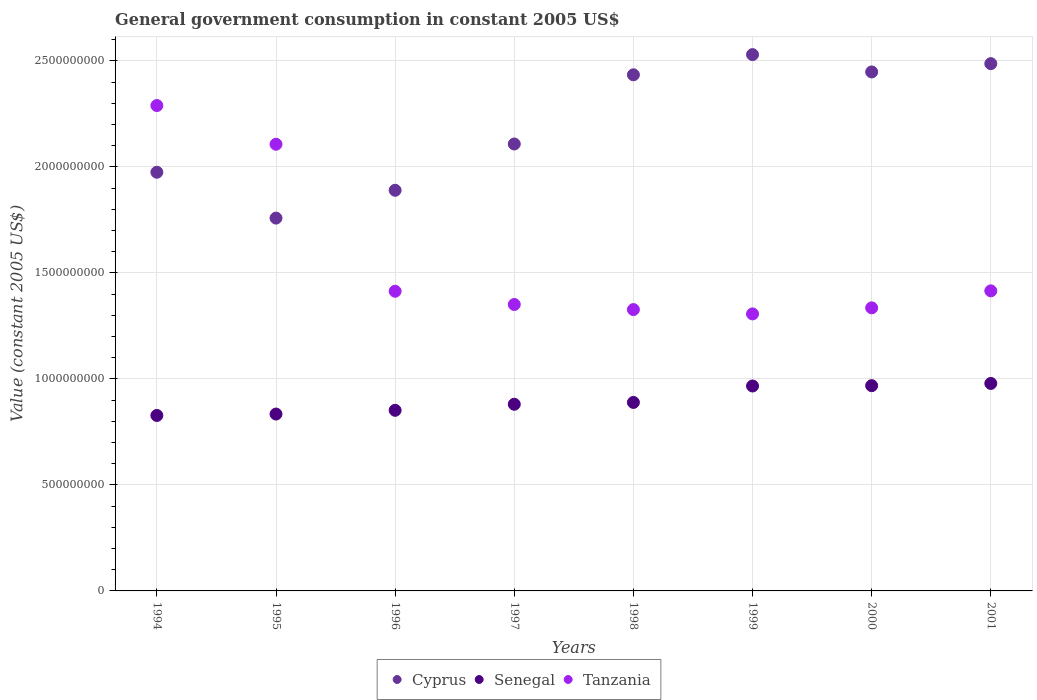Is the number of dotlines equal to the number of legend labels?
Your response must be concise. Yes. What is the government conusmption in Cyprus in 1996?
Your response must be concise. 1.89e+09. Across all years, what is the maximum government conusmption in Senegal?
Provide a succinct answer. 9.79e+08. Across all years, what is the minimum government conusmption in Tanzania?
Offer a very short reply. 1.31e+09. In which year was the government conusmption in Cyprus maximum?
Keep it short and to the point. 1999. In which year was the government conusmption in Cyprus minimum?
Provide a succinct answer. 1995. What is the total government conusmption in Tanzania in the graph?
Your answer should be compact. 1.25e+1. What is the difference between the government conusmption in Tanzania in 1997 and that in 2000?
Offer a very short reply. 1.59e+07. What is the difference between the government conusmption in Senegal in 1997 and the government conusmption in Tanzania in 1996?
Keep it short and to the point. -5.33e+08. What is the average government conusmption in Tanzania per year?
Give a very brief answer. 1.57e+09. In the year 1997, what is the difference between the government conusmption in Senegal and government conusmption in Tanzania?
Your answer should be compact. -4.71e+08. What is the ratio of the government conusmption in Tanzania in 1994 to that in 2001?
Offer a very short reply. 1.62. What is the difference between the highest and the second highest government conusmption in Cyprus?
Offer a very short reply. 4.25e+07. What is the difference between the highest and the lowest government conusmption in Senegal?
Ensure brevity in your answer.  1.51e+08. Is it the case that in every year, the sum of the government conusmption in Tanzania and government conusmption in Cyprus  is greater than the government conusmption in Senegal?
Provide a succinct answer. Yes. Is the government conusmption in Senegal strictly greater than the government conusmption in Tanzania over the years?
Give a very brief answer. No. Is the government conusmption in Tanzania strictly less than the government conusmption in Senegal over the years?
Offer a terse response. No. How many dotlines are there?
Your response must be concise. 3. Are the values on the major ticks of Y-axis written in scientific E-notation?
Ensure brevity in your answer.  No. Where does the legend appear in the graph?
Provide a succinct answer. Bottom center. What is the title of the graph?
Ensure brevity in your answer.  General government consumption in constant 2005 US$. Does "Israel" appear as one of the legend labels in the graph?
Your answer should be compact. No. What is the label or title of the Y-axis?
Provide a short and direct response. Value (constant 2005 US$). What is the Value (constant 2005 US$) of Cyprus in 1994?
Your response must be concise. 1.97e+09. What is the Value (constant 2005 US$) in Senegal in 1994?
Offer a very short reply. 8.28e+08. What is the Value (constant 2005 US$) of Tanzania in 1994?
Offer a very short reply. 2.29e+09. What is the Value (constant 2005 US$) in Cyprus in 1995?
Your answer should be compact. 1.76e+09. What is the Value (constant 2005 US$) in Senegal in 1995?
Offer a very short reply. 8.34e+08. What is the Value (constant 2005 US$) of Tanzania in 1995?
Make the answer very short. 2.11e+09. What is the Value (constant 2005 US$) of Cyprus in 1996?
Give a very brief answer. 1.89e+09. What is the Value (constant 2005 US$) of Senegal in 1996?
Provide a succinct answer. 8.52e+08. What is the Value (constant 2005 US$) of Tanzania in 1996?
Provide a short and direct response. 1.41e+09. What is the Value (constant 2005 US$) in Cyprus in 1997?
Your answer should be very brief. 2.11e+09. What is the Value (constant 2005 US$) of Senegal in 1997?
Provide a short and direct response. 8.80e+08. What is the Value (constant 2005 US$) in Tanzania in 1997?
Offer a very short reply. 1.35e+09. What is the Value (constant 2005 US$) of Cyprus in 1998?
Keep it short and to the point. 2.43e+09. What is the Value (constant 2005 US$) of Senegal in 1998?
Offer a very short reply. 8.89e+08. What is the Value (constant 2005 US$) in Tanzania in 1998?
Give a very brief answer. 1.33e+09. What is the Value (constant 2005 US$) in Cyprus in 1999?
Give a very brief answer. 2.53e+09. What is the Value (constant 2005 US$) in Senegal in 1999?
Provide a succinct answer. 9.67e+08. What is the Value (constant 2005 US$) of Tanzania in 1999?
Make the answer very short. 1.31e+09. What is the Value (constant 2005 US$) in Cyprus in 2000?
Offer a terse response. 2.45e+09. What is the Value (constant 2005 US$) of Senegal in 2000?
Offer a very short reply. 9.68e+08. What is the Value (constant 2005 US$) of Tanzania in 2000?
Provide a short and direct response. 1.34e+09. What is the Value (constant 2005 US$) of Cyprus in 2001?
Ensure brevity in your answer.  2.49e+09. What is the Value (constant 2005 US$) in Senegal in 2001?
Provide a succinct answer. 9.79e+08. What is the Value (constant 2005 US$) of Tanzania in 2001?
Make the answer very short. 1.42e+09. Across all years, what is the maximum Value (constant 2005 US$) of Cyprus?
Ensure brevity in your answer.  2.53e+09. Across all years, what is the maximum Value (constant 2005 US$) of Senegal?
Keep it short and to the point. 9.79e+08. Across all years, what is the maximum Value (constant 2005 US$) of Tanzania?
Make the answer very short. 2.29e+09. Across all years, what is the minimum Value (constant 2005 US$) in Cyprus?
Ensure brevity in your answer.  1.76e+09. Across all years, what is the minimum Value (constant 2005 US$) in Senegal?
Offer a terse response. 8.28e+08. Across all years, what is the minimum Value (constant 2005 US$) of Tanzania?
Provide a succinct answer. 1.31e+09. What is the total Value (constant 2005 US$) of Cyprus in the graph?
Provide a short and direct response. 1.76e+1. What is the total Value (constant 2005 US$) of Senegal in the graph?
Your answer should be very brief. 7.20e+09. What is the total Value (constant 2005 US$) of Tanzania in the graph?
Give a very brief answer. 1.25e+1. What is the difference between the Value (constant 2005 US$) of Cyprus in 1994 and that in 1995?
Provide a short and direct response. 2.16e+08. What is the difference between the Value (constant 2005 US$) in Senegal in 1994 and that in 1995?
Make the answer very short. -6.63e+06. What is the difference between the Value (constant 2005 US$) in Tanzania in 1994 and that in 1995?
Offer a terse response. 1.83e+08. What is the difference between the Value (constant 2005 US$) of Cyprus in 1994 and that in 1996?
Make the answer very short. 8.51e+07. What is the difference between the Value (constant 2005 US$) of Senegal in 1994 and that in 1996?
Your response must be concise. -2.43e+07. What is the difference between the Value (constant 2005 US$) of Tanzania in 1994 and that in 1996?
Offer a terse response. 8.76e+08. What is the difference between the Value (constant 2005 US$) of Cyprus in 1994 and that in 1997?
Your response must be concise. -1.33e+08. What is the difference between the Value (constant 2005 US$) in Senegal in 1994 and that in 1997?
Your response must be concise. -5.28e+07. What is the difference between the Value (constant 2005 US$) of Tanzania in 1994 and that in 1997?
Provide a succinct answer. 9.38e+08. What is the difference between the Value (constant 2005 US$) of Cyprus in 1994 and that in 1998?
Offer a terse response. -4.60e+08. What is the difference between the Value (constant 2005 US$) of Senegal in 1994 and that in 1998?
Keep it short and to the point. -6.14e+07. What is the difference between the Value (constant 2005 US$) of Tanzania in 1994 and that in 1998?
Keep it short and to the point. 9.62e+08. What is the difference between the Value (constant 2005 US$) in Cyprus in 1994 and that in 1999?
Your answer should be very brief. -5.55e+08. What is the difference between the Value (constant 2005 US$) of Senegal in 1994 and that in 1999?
Keep it short and to the point. -1.39e+08. What is the difference between the Value (constant 2005 US$) of Tanzania in 1994 and that in 1999?
Your answer should be compact. 9.83e+08. What is the difference between the Value (constant 2005 US$) in Cyprus in 1994 and that in 2000?
Ensure brevity in your answer.  -4.73e+08. What is the difference between the Value (constant 2005 US$) of Senegal in 1994 and that in 2000?
Provide a short and direct response. -1.41e+08. What is the difference between the Value (constant 2005 US$) of Tanzania in 1994 and that in 2000?
Your answer should be very brief. 9.54e+08. What is the difference between the Value (constant 2005 US$) of Cyprus in 1994 and that in 2001?
Make the answer very short. -5.12e+08. What is the difference between the Value (constant 2005 US$) of Senegal in 1994 and that in 2001?
Your response must be concise. -1.51e+08. What is the difference between the Value (constant 2005 US$) in Tanzania in 1994 and that in 2001?
Your answer should be very brief. 8.74e+08. What is the difference between the Value (constant 2005 US$) of Cyprus in 1995 and that in 1996?
Your answer should be very brief. -1.31e+08. What is the difference between the Value (constant 2005 US$) of Senegal in 1995 and that in 1996?
Give a very brief answer. -1.76e+07. What is the difference between the Value (constant 2005 US$) in Tanzania in 1995 and that in 1996?
Your response must be concise. 6.93e+08. What is the difference between the Value (constant 2005 US$) of Cyprus in 1995 and that in 1997?
Give a very brief answer. -3.50e+08. What is the difference between the Value (constant 2005 US$) in Senegal in 1995 and that in 1997?
Provide a short and direct response. -4.61e+07. What is the difference between the Value (constant 2005 US$) of Tanzania in 1995 and that in 1997?
Provide a succinct answer. 7.56e+08. What is the difference between the Value (constant 2005 US$) of Cyprus in 1995 and that in 1998?
Your answer should be compact. -6.76e+08. What is the difference between the Value (constant 2005 US$) of Senegal in 1995 and that in 1998?
Give a very brief answer. -5.48e+07. What is the difference between the Value (constant 2005 US$) of Tanzania in 1995 and that in 1998?
Keep it short and to the point. 7.80e+08. What is the difference between the Value (constant 2005 US$) of Cyprus in 1995 and that in 1999?
Your answer should be very brief. -7.71e+08. What is the difference between the Value (constant 2005 US$) in Senegal in 1995 and that in 1999?
Your answer should be very brief. -1.32e+08. What is the difference between the Value (constant 2005 US$) in Tanzania in 1995 and that in 1999?
Give a very brief answer. 8.00e+08. What is the difference between the Value (constant 2005 US$) in Cyprus in 1995 and that in 2000?
Ensure brevity in your answer.  -6.89e+08. What is the difference between the Value (constant 2005 US$) of Senegal in 1995 and that in 2000?
Give a very brief answer. -1.34e+08. What is the difference between the Value (constant 2005 US$) of Tanzania in 1995 and that in 2000?
Provide a short and direct response. 7.72e+08. What is the difference between the Value (constant 2005 US$) of Cyprus in 1995 and that in 2001?
Provide a succinct answer. -7.29e+08. What is the difference between the Value (constant 2005 US$) of Senegal in 1995 and that in 2001?
Give a very brief answer. -1.44e+08. What is the difference between the Value (constant 2005 US$) of Tanzania in 1995 and that in 2001?
Ensure brevity in your answer.  6.92e+08. What is the difference between the Value (constant 2005 US$) in Cyprus in 1996 and that in 1997?
Your answer should be compact. -2.18e+08. What is the difference between the Value (constant 2005 US$) in Senegal in 1996 and that in 1997?
Make the answer very short. -2.85e+07. What is the difference between the Value (constant 2005 US$) of Tanzania in 1996 and that in 1997?
Your response must be concise. 6.24e+07. What is the difference between the Value (constant 2005 US$) of Cyprus in 1996 and that in 1998?
Provide a short and direct response. -5.45e+08. What is the difference between the Value (constant 2005 US$) of Senegal in 1996 and that in 1998?
Give a very brief answer. -3.72e+07. What is the difference between the Value (constant 2005 US$) in Tanzania in 1996 and that in 1998?
Your answer should be compact. 8.64e+07. What is the difference between the Value (constant 2005 US$) in Cyprus in 1996 and that in 1999?
Keep it short and to the point. -6.40e+08. What is the difference between the Value (constant 2005 US$) in Senegal in 1996 and that in 1999?
Keep it short and to the point. -1.15e+08. What is the difference between the Value (constant 2005 US$) of Tanzania in 1996 and that in 1999?
Give a very brief answer. 1.07e+08. What is the difference between the Value (constant 2005 US$) of Cyprus in 1996 and that in 2000?
Offer a very short reply. -5.58e+08. What is the difference between the Value (constant 2005 US$) in Senegal in 1996 and that in 2000?
Your answer should be very brief. -1.16e+08. What is the difference between the Value (constant 2005 US$) of Tanzania in 1996 and that in 2000?
Give a very brief answer. 7.83e+07. What is the difference between the Value (constant 2005 US$) in Cyprus in 1996 and that in 2001?
Your answer should be compact. -5.97e+08. What is the difference between the Value (constant 2005 US$) in Senegal in 1996 and that in 2001?
Ensure brevity in your answer.  -1.27e+08. What is the difference between the Value (constant 2005 US$) of Tanzania in 1996 and that in 2001?
Offer a terse response. -1.82e+06. What is the difference between the Value (constant 2005 US$) in Cyprus in 1997 and that in 1998?
Your answer should be compact. -3.26e+08. What is the difference between the Value (constant 2005 US$) in Senegal in 1997 and that in 1998?
Provide a short and direct response. -8.65e+06. What is the difference between the Value (constant 2005 US$) of Tanzania in 1997 and that in 1998?
Offer a very short reply. 2.41e+07. What is the difference between the Value (constant 2005 US$) of Cyprus in 1997 and that in 1999?
Your answer should be compact. -4.22e+08. What is the difference between the Value (constant 2005 US$) in Senegal in 1997 and that in 1999?
Keep it short and to the point. -8.62e+07. What is the difference between the Value (constant 2005 US$) in Tanzania in 1997 and that in 1999?
Keep it short and to the point. 4.45e+07. What is the difference between the Value (constant 2005 US$) of Cyprus in 1997 and that in 2000?
Ensure brevity in your answer.  -3.40e+08. What is the difference between the Value (constant 2005 US$) of Senegal in 1997 and that in 2000?
Provide a succinct answer. -8.77e+07. What is the difference between the Value (constant 2005 US$) in Tanzania in 1997 and that in 2000?
Ensure brevity in your answer.  1.59e+07. What is the difference between the Value (constant 2005 US$) in Cyprus in 1997 and that in 2001?
Provide a succinct answer. -3.79e+08. What is the difference between the Value (constant 2005 US$) in Senegal in 1997 and that in 2001?
Provide a succinct answer. -9.82e+07. What is the difference between the Value (constant 2005 US$) in Tanzania in 1997 and that in 2001?
Ensure brevity in your answer.  -6.42e+07. What is the difference between the Value (constant 2005 US$) of Cyprus in 1998 and that in 1999?
Provide a succinct answer. -9.52e+07. What is the difference between the Value (constant 2005 US$) of Senegal in 1998 and that in 1999?
Your answer should be compact. -7.76e+07. What is the difference between the Value (constant 2005 US$) of Tanzania in 1998 and that in 1999?
Provide a short and direct response. 2.05e+07. What is the difference between the Value (constant 2005 US$) in Cyprus in 1998 and that in 2000?
Provide a short and direct response. -1.35e+07. What is the difference between the Value (constant 2005 US$) in Senegal in 1998 and that in 2000?
Give a very brief answer. -7.91e+07. What is the difference between the Value (constant 2005 US$) of Tanzania in 1998 and that in 2000?
Offer a terse response. -8.16e+06. What is the difference between the Value (constant 2005 US$) in Cyprus in 1998 and that in 2001?
Keep it short and to the point. -5.26e+07. What is the difference between the Value (constant 2005 US$) of Senegal in 1998 and that in 2001?
Your response must be concise. -8.96e+07. What is the difference between the Value (constant 2005 US$) in Tanzania in 1998 and that in 2001?
Your response must be concise. -8.83e+07. What is the difference between the Value (constant 2005 US$) in Cyprus in 1999 and that in 2000?
Give a very brief answer. 8.17e+07. What is the difference between the Value (constant 2005 US$) in Senegal in 1999 and that in 2000?
Provide a succinct answer. -1.54e+06. What is the difference between the Value (constant 2005 US$) in Tanzania in 1999 and that in 2000?
Ensure brevity in your answer.  -2.86e+07. What is the difference between the Value (constant 2005 US$) of Cyprus in 1999 and that in 2001?
Offer a very short reply. 4.25e+07. What is the difference between the Value (constant 2005 US$) of Senegal in 1999 and that in 2001?
Your answer should be very brief. -1.20e+07. What is the difference between the Value (constant 2005 US$) in Tanzania in 1999 and that in 2001?
Offer a terse response. -1.09e+08. What is the difference between the Value (constant 2005 US$) in Cyprus in 2000 and that in 2001?
Give a very brief answer. -3.92e+07. What is the difference between the Value (constant 2005 US$) of Senegal in 2000 and that in 2001?
Make the answer very short. -1.05e+07. What is the difference between the Value (constant 2005 US$) in Tanzania in 2000 and that in 2001?
Offer a very short reply. -8.01e+07. What is the difference between the Value (constant 2005 US$) in Cyprus in 1994 and the Value (constant 2005 US$) in Senegal in 1995?
Give a very brief answer. 1.14e+09. What is the difference between the Value (constant 2005 US$) of Cyprus in 1994 and the Value (constant 2005 US$) of Tanzania in 1995?
Ensure brevity in your answer.  -1.32e+08. What is the difference between the Value (constant 2005 US$) in Senegal in 1994 and the Value (constant 2005 US$) in Tanzania in 1995?
Keep it short and to the point. -1.28e+09. What is the difference between the Value (constant 2005 US$) of Cyprus in 1994 and the Value (constant 2005 US$) of Senegal in 1996?
Keep it short and to the point. 1.12e+09. What is the difference between the Value (constant 2005 US$) of Cyprus in 1994 and the Value (constant 2005 US$) of Tanzania in 1996?
Keep it short and to the point. 5.61e+08. What is the difference between the Value (constant 2005 US$) of Senegal in 1994 and the Value (constant 2005 US$) of Tanzania in 1996?
Keep it short and to the point. -5.86e+08. What is the difference between the Value (constant 2005 US$) in Cyprus in 1994 and the Value (constant 2005 US$) in Senegal in 1997?
Give a very brief answer. 1.09e+09. What is the difference between the Value (constant 2005 US$) in Cyprus in 1994 and the Value (constant 2005 US$) in Tanzania in 1997?
Offer a terse response. 6.24e+08. What is the difference between the Value (constant 2005 US$) of Senegal in 1994 and the Value (constant 2005 US$) of Tanzania in 1997?
Give a very brief answer. -5.23e+08. What is the difference between the Value (constant 2005 US$) in Cyprus in 1994 and the Value (constant 2005 US$) in Senegal in 1998?
Offer a terse response. 1.09e+09. What is the difference between the Value (constant 2005 US$) in Cyprus in 1994 and the Value (constant 2005 US$) in Tanzania in 1998?
Your response must be concise. 6.48e+08. What is the difference between the Value (constant 2005 US$) of Senegal in 1994 and the Value (constant 2005 US$) of Tanzania in 1998?
Offer a terse response. -4.99e+08. What is the difference between the Value (constant 2005 US$) of Cyprus in 1994 and the Value (constant 2005 US$) of Senegal in 1999?
Offer a very short reply. 1.01e+09. What is the difference between the Value (constant 2005 US$) of Cyprus in 1994 and the Value (constant 2005 US$) of Tanzania in 1999?
Keep it short and to the point. 6.68e+08. What is the difference between the Value (constant 2005 US$) of Senegal in 1994 and the Value (constant 2005 US$) of Tanzania in 1999?
Offer a terse response. -4.79e+08. What is the difference between the Value (constant 2005 US$) of Cyprus in 1994 and the Value (constant 2005 US$) of Senegal in 2000?
Your response must be concise. 1.01e+09. What is the difference between the Value (constant 2005 US$) of Cyprus in 1994 and the Value (constant 2005 US$) of Tanzania in 2000?
Keep it short and to the point. 6.40e+08. What is the difference between the Value (constant 2005 US$) in Senegal in 1994 and the Value (constant 2005 US$) in Tanzania in 2000?
Make the answer very short. -5.08e+08. What is the difference between the Value (constant 2005 US$) of Cyprus in 1994 and the Value (constant 2005 US$) of Senegal in 2001?
Ensure brevity in your answer.  9.96e+08. What is the difference between the Value (constant 2005 US$) in Cyprus in 1994 and the Value (constant 2005 US$) in Tanzania in 2001?
Keep it short and to the point. 5.59e+08. What is the difference between the Value (constant 2005 US$) of Senegal in 1994 and the Value (constant 2005 US$) of Tanzania in 2001?
Make the answer very short. -5.88e+08. What is the difference between the Value (constant 2005 US$) in Cyprus in 1995 and the Value (constant 2005 US$) in Senegal in 1996?
Provide a succinct answer. 9.07e+08. What is the difference between the Value (constant 2005 US$) in Cyprus in 1995 and the Value (constant 2005 US$) in Tanzania in 1996?
Your response must be concise. 3.45e+08. What is the difference between the Value (constant 2005 US$) in Senegal in 1995 and the Value (constant 2005 US$) in Tanzania in 1996?
Offer a terse response. -5.79e+08. What is the difference between the Value (constant 2005 US$) of Cyprus in 1995 and the Value (constant 2005 US$) of Senegal in 1997?
Your answer should be compact. 8.78e+08. What is the difference between the Value (constant 2005 US$) of Cyprus in 1995 and the Value (constant 2005 US$) of Tanzania in 1997?
Provide a short and direct response. 4.07e+08. What is the difference between the Value (constant 2005 US$) in Senegal in 1995 and the Value (constant 2005 US$) in Tanzania in 1997?
Offer a terse response. -5.17e+08. What is the difference between the Value (constant 2005 US$) in Cyprus in 1995 and the Value (constant 2005 US$) in Senegal in 1998?
Provide a succinct answer. 8.69e+08. What is the difference between the Value (constant 2005 US$) of Cyprus in 1995 and the Value (constant 2005 US$) of Tanzania in 1998?
Offer a terse response. 4.32e+08. What is the difference between the Value (constant 2005 US$) in Senegal in 1995 and the Value (constant 2005 US$) in Tanzania in 1998?
Keep it short and to the point. -4.93e+08. What is the difference between the Value (constant 2005 US$) in Cyprus in 1995 and the Value (constant 2005 US$) in Senegal in 1999?
Offer a terse response. 7.92e+08. What is the difference between the Value (constant 2005 US$) of Cyprus in 1995 and the Value (constant 2005 US$) of Tanzania in 1999?
Ensure brevity in your answer.  4.52e+08. What is the difference between the Value (constant 2005 US$) in Senegal in 1995 and the Value (constant 2005 US$) in Tanzania in 1999?
Offer a very short reply. -4.72e+08. What is the difference between the Value (constant 2005 US$) of Cyprus in 1995 and the Value (constant 2005 US$) of Senegal in 2000?
Give a very brief answer. 7.90e+08. What is the difference between the Value (constant 2005 US$) of Cyprus in 1995 and the Value (constant 2005 US$) of Tanzania in 2000?
Your response must be concise. 4.23e+08. What is the difference between the Value (constant 2005 US$) of Senegal in 1995 and the Value (constant 2005 US$) of Tanzania in 2000?
Your answer should be compact. -5.01e+08. What is the difference between the Value (constant 2005 US$) in Cyprus in 1995 and the Value (constant 2005 US$) in Senegal in 2001?
Your answer should be very brief. 7.80e+08. What is the difference between the Value (constant 2005 US$) of Cyprus in 1995 and the Value (constant 2005 US$) of Tanzania in 2001?
Offer a terse response. 3.43e+08. What is the difference between the Value (constant 2005 US$) of Senegal in 1995 and the Value (constant 2005 US$) of Tanzania in 2001?
Keep it short and to the point. -5.81e+08. What is the difference between the Value (constant 2005 US$) of Cyprus in 1996 and the Value (constant 2005 US$) of Senegal in 1997?
Your answer should be compact. 1.01e+09. What is the difference between the Value (constant 2005 US$) in Cyprus in 1996 and the Value (constant 2005 US$) in Tanzania in 1997?
Your response must be concise. 5.39e+08. What is the difference between the Value (constant 2005 US$) of Senegal in 1996 and the Value (constant 2005 US$) of Tanzania in 1997?
Give a very brief answer. -4.99e+08. What is the difference between the Value (constant 2005 US$) of Cyprus in 1996 and the Value (constant 2005 US$) of Senegal in 1998?
Offer a terse response. 1.00e+09. What is the difference between the Value (constant 2005 US$) in Cyprus in 1996 and the Value (constant 2005 US$) in Tanzania in 1998?
Your answer should be compact. 5.63e+08. What is the difference between the Value (constant 2005 US$) in Senegal in 1996 and the Value (constant 2005 US$) in Tanzania in 1998?
Keep it short and to the point. -4.75e+08. What is the difference between the Value (constant 2005 US$) of Cyprus in 1996 and the Value (constant 2005 US$) of Senegal in 1999?
Give a very brief answer. 9.23e+08. What is the difference between the Value (constant 2005 US$) of Cyprus in 1996 and the Value (constant 2005 US$) of Tanzania in 1999?
Offer a very short reply. 5.83e+08. What is the difference between the Value (constant 2005 US$) of Senegal in 1996 and the Value (constant 2005 US$) of Tanzania in 1999?
Give a very brief answer. -4.55e+08. What is the difference between the Value (constant 2005 US$) of Cyprus in 1996 and the Value (constant 2005 US$) of Senegal in 2000?
Ensure brevity in your answer.  9.22e+08. What is the difference between the Value (constant 2005 US$) in Cyprus in 1996 and the Value (constant 2005 US$) in Tanzania in 2000?
Provide a short and direct response. 5.55e+08. What is the difference between the Value (constant 2005 US$) of Senegal in 1996 and the Value (constant 2005 US$) of Tanzania in 2000?
Offer a very short reply. -4.83e+08. What is the difference between the Value (constant 2005 US$) of Cyprus in 1996 and the Value (constant 2005 US$) of Senegal in 2001?
Your response must be concise. 9.11e+08. What is the difference between the Value (constant 2005 US$) in Cyprus in 1996 and the Value (constant 2005 US$) in Tanzania in 2001?
Make the answer very short. 4.74e+08. What is the difference between the Value (constant 2005 US$) of Senegal in 1996 and the Value (constant 2005 US$) of Tanzania in 2001?
Provide a short and direct response. -5.63e+08. What is the difference between the Value (constant 2005 US$) in Cyprus in 1997 and the Value (constant 2005 US$) in Senegal in 1998?
Your answer should be compact. 1.22e+09. What is the difference between the Value (constant 2005 US$) in Cyprus in 1997 and the Value (constant 2005 US$) in Tanzania in 1998?
Keep it short and to the point. 7.81e+08. What is the difference between the Value (constant 2005 US$) in Senegal in 1997 and the Value (constant 2005 US$) in Tanzania in 1998?
Provide a succinct answer. -4.47e+08. What is the difference between the Value (constant 2005 US$) in Cyprus in 1997 and the Value (constant 2005 US$) in Senegal in 1999?
Offer a terse response. 1.14e+09. What is the difference between the Value (constant 2005 US$) of Cyprus in 1997 and the Value (constant 2005 US$) of Tanzania in 1999?
Provide a short and direct response. 8.01e+08. What is the difference between the Value (constant 2005 US$) in Senegal in 1997 and the Value (constant 2005 US$) in Tanzania in 1999?
Provide a succinct answer. -4.26e+08. What is the difference between the Value (constant 2005 US$) in Cyprus in 1997 and the Value (constant 2005 US$) in Senegal in 2000?
Provide a succinct answer. 1.14e+09. What is the difference between the Value (constant 2005 US$) in Cyprus in 1997 and the Value (constant 2005 US$) in Tanzania in 2000?
Offer a very short reply. 7.73e+08. What is the difference between the Value (constant 2005 US$) in Senegal in 1997 and the Value (constant 2005 US$) in Tanzania in 2000?
Provide a succinct answer. -4.55e+08. What is the difference between the Value (constant 2005 US$) in Cyprus in 1997 and the Value (constant 2005 US$) in Senegal in 2001?
Ensure brevity in your answer.  1.13e+09. What is the difference between the Value (constant 2005 US$) of Cyprus in 1997 and the Value (constant 2005 US$) of Tanzania in 2001?
Your answer should be compact. 6.93e+08. What is the difference between the Value (constant 2005 US$) of Senegal in 1997 and the Value (constant 2005 US$) of Tanzania in 2001?
Make the answer very short. -5.35e+08. What is the difference between the Value (constant 2005 US$) of Cyprus in 1998 and the Value (constant 2005 US$) of Senegal in 1999?
Provide a succinct answer. 1.47e+09. What is the difference between the Value (constant 2005 US$) in Cyprus in 1998 and the Value (constant 2005 US$) in Tanzania in 1999?
Offer a very short reply. 1.13e+09. What is the difference between the Value (constant 2005 US$) in Senegal in 1998 and the Value (constant 2005 US$) in Tanzania in 1999?
Give a very brief answer. -4.17e+08. What is the difference between the Value (constant 2005 US$) of Cyprus in 1998 and the Value (constant 2005 US$) of Senegal in 2000?
Offer a very short reply. 1.47e+09. What is the difference between the Value (constant 2005 US$) in Cyprus in 1998 and the Value (constant 2005 US$) in Tanzania in 2000?
Make the answer very short. 1.10e+09. What is the difference between the Value (constant 2005 US$) of Senegal in 1998 and the Value (constant 2005 US$) of Tanzania in 2000?
Provide a short and direct response. -4.46e+08. What is the difference between the Value (constant 2005 US$) of Cyprus in 1998 and the Value (constant 2005 US$) of Senegal in 2001?
Your response must be concise. 1.46e+09. What is the difference between the Value (constant 2005 US$) in Cyprus in 1998 and the Value (constant 2005 US$) in Tanzania in 2001?
Give a very brief answer. 1.02e+09. What is the difference between the Value (constant 2005 US$) in Senegal in 1998 and the Value (constant 2005 US$) in Tanzania in 2001?
Provide a succinct answer. -5.26e+08. What is the difference between the Value (constant 2005 US$) in Cyprus in 1999 and the Value (constant 2005 US$) in Senegal in 2000?
Your response must be concise. 1.56e+09. What is the difference between the Value (constant 2005 US$) in Cyprus in 1999 and the Value (constant 2005 US$) in Tanzania in 2000?
Provide a succinct answer. 1.19e+09. What is the difference between the Value (constant 2005 US$) in Senegal in 1999 and the Value (constant 2005 US$) in Tanzania in 2000?
Ensure brevity in your answer.  -3.69e+08. What is the difference between the Value (constant 2005 US$) of Cyprus in 1999 and the Value (constant 2005 US$) of Senegal in 2001?
Offer a terse response. 1.55e+09. What is the difference between the Value (constant 2005 US$) of Cyprus in 1999 and the Value (constant 2005 US$) of Tanzania in 2001?
Make the answer very short. 1.11e+09. What is the difference between the Value (constant 2005 US$) of Senegal in 1999 and the Value (constant 2005 US$) of Tanzania in 2001?
Offer a very short reply. -4.49e+08. What is the difference between the Value (constant 2005 US$) in Cyprus in 2000 and the Value (constant 2005 US$) in Senegal in 2001?
Make the answer very short. 1.47e+09. What is the difference between the Value (constant 2005 US$) of Cyprus in 2000 and the Value (constant 2005 US$) of Tanzania in 2001?
Ensure brevity in your answer.  1.03e+09. What is the difference between the Value (constant 2005 US$) in Senegal in 2000 and the Value (constant 2005 US$) in Tanzania in 2001?
Your response must be concise. -4.47e+08. What is the average Value (constant 2005 US$) of Cyprus per year?
Provide a short and direct response. 2.20e+09. What is the average Value (constant 2005 US$) in Senegal per year?
Provide a short and direct response. 9.00e+08. What is the average Value (constant 2005 US$) in Tanzania per year?
Keep it short and to the point. 1.57e+09. In the year 1994, what is the difference between the Value (constant 2005 US$) of Cyprus and Value (constant 2005 US$) of Senegal?
Provide a short and direct response. 1.15e+09. In the year 1994, what is the difference between the Value (constant 2005 US$) in Cyprus and Value (constant 2005 US$) in Tanzania?
Your response must be concise. -3.15e+08. In the year 1994, what is the difference between the Value (constant 2005 US$) in Senegal and Value (constant 2005 US$) in Tanzania?
Provide a short and direct response. -1.46e+09. In the year 1995, what is the difference between the Value (constant 2005 US$) of Cyprus and Value (constant 2005 US$) of Senegal?
Give a very brief answer. 9.24e+08. In the year 1995, what is the difference between the Value (constant 2005 US$) in Cyprus and Value (constant 2005 US$) in Tanzania?
Provide a short and direct response. -3.48e+08. In the year 1995, what is the difference between the Value (constant 2005 US$) of Senegal and Value (constant 2005 US$) of Tanzania?
Offer a very short reply. -1.27e+09. In the year 1996, what is the difference between the Value (constant 2005 US$) of Cyprus and Value (constant 2005 US$) of Senegal?
Keep it short and to the point. 1.04e+09. In the year 1996, what is the difference between the Value (constant 2005 US$) of Cyprus and Value (constant 2005 US$) of Tanzania?
Your answer should be compact. 4.76e+08. In the year 1996, what is the difference between the Value (constant 2005 US$) in Senegal and Value (constant 2005 US$) in Tanzania?
Provide a succinct answer. -5.62e+08. In the year 1997, what is the difference between the Value (constant 2005 US$) in Cyprus and Value (constant 2005 US$) in Senegal?
Provide a succinct answer. 1.23e+09. In the year 1997, what is the difference between the Value (constant 2005 US$) of Cyprus and Value (constant 2005 US$) of Tanzania?
Your response must be concise. 7.57e+08. In the year 1997, what is the difference between the Value (constant 2005 US$) in Senegal and Value (constant 2005 US$) in Tanzania?
Provide a short and direct response. -4.71e+08. In the year 1998, what is the difference between the Value (constant 2005 US$) of Cyprus and Value (constant 2005 US$) of Senegal?
Give a very brief answer. 1.55e+09. In the year 1998, what is the difference between the Value (constant 2005 US$) in Cyprus and Value (constant 2005 US$) in Tanzania?
Provide a succinct answer. 1.11e+09. In the year 1998, what is the difference between the Value (constant 2005 US$) of Senegal and Value (constant 2005 US$) of Tanzania?
Offer a very short reply. -4.38e+08. In the year 1999, what is the difference between the Value (constant 2005 US$) in Cyprus and Value (constant 2005 US$) in Senegal?
Offer a very short reply. 1.56e+09. In the year 1999, what is the difference between the Value (constant 2005 US$) in Cyprus and Value (constant 2005 US$) in Tanzania?
Provide a short and direct response. 1.22e+09. In the year 1999, what is the difference between the Value (constant 2005 US$) of Senegal and Value (constant 2005 US$) of Tanzania?
Keep it short and to the point. -3.40e+08. In the year 2000, what is the difference between the Value (constant 2005 US$) in Cyprus and Value (constant 2005 US$) in Senegal?
Offer a very short reply. 1.48e+09. In the year 2000, what is the difference between the Value (constant 2005 US$) in Cyprus and Value (constant 2005 US$) in Tanzania?
Offer a very short reply. 1.11e+09. In the year 2000, what is the difference between the Value (constant 2005 US$) in Senegal and Value (constant 2005 US$) in Tanzania?
Ensure brevity in your answer.  -3.67e+08. In the year 2001, what is the difference between the Value (constant 2005 US$) in Cyprus and Value (constant 2005 US$) in Senegal?
Your response must be concise. 1.51e+09. In the year 2001, what is the difference between the Value (constant 2005 US$) of Cyprus and Value (constant 2005 US$) of Tanzania?
Your answer should be very brief. 1.07e+09. In the year 2001, what is the difference between the Value (constant 2005 US$) of Senegal and Value (constant 2005 US$) of Tanzania?
Keep it short and to the point. -4.37e+08. What is the ratio of the Value (constant 2005 US$) of Cyprus in 1994 to that in 1995?
Keep it short and to the point. 1.12. What is the ratio of the Value (constant 2005 US$) of Senegal in 1994 to that in 1995?
Make the answer very short. 0.99. What is the ratio of the Value (constant 2005 US$) of Tanzania in 1994 to that in 1995?
Offer a very short reply. 1.09. What is the ratio of the Value (constant 2005 US$) in Cyprus in 1994 to that in 1996?
Give a very brief answer. 1.04. What is the ratio of the Value (constant 2005 US$) in Senegal in 1994 to that in 1996?
Ensure brevity in your answer.  0.97. What is the ratio of the Value (constant 2005 US$) in Tanzania in 1994 to that in 1996?
Provide a short and direct response. 1.62. What is the ratio of the Value (constant 2005 US$) of Cyprus in 1994 to that in 1997?
Offer a very short reply. 0.94. What is the ratio of the Value (constant 2005 US$) of Senegal in 1994 to that in 1997?
Keep it short and to the point. 0.94. What is the ratio of the Value (constant 2005 US$) of Tanzania in 1994 to that in 1997?
Provide a short and direct response. 1.69. What is the ratio of the Value (constant 2005 US$) of Cyprus in 1994 to that in 1998?
Offer a terse response. 0.81. What is the ratio of the Value (constant 2005 US$) in Senegal in 1994 to that in 1998?
Give a very brief answer. 0.93. What is the ratio of the Value (constant 2005 US$) of Tanzania in 1994 to that in 1998?
Your answer should be compact. 1.73. What is the ratio of the Value (constant 2005 US$) in Cyprus in 1994 to that in 1999?
Provide a succinct answer. 0.78. What is the ratio of the Value (constant 2005 US$) of Senegal in 1994 to that in 1999?
Provide a short and direct response. 0.86. What is the ratio of the Value (constant 2005 US$) in Tanzania in 1994 to that in 1999?
Offer a terse response. 1.75. What is the ratio of the Value (constant 2005 US$) in Cyprus in 1994 to that in 2000?
Provide a short and direct response. 0.81. What is the ratio of the Value (constant 2005 US$) of Senegal in 1994 to that in 2000?
Keep it short and to the point. 0.85. What is the ratio of the Value (constant 2005 US$) in Tanzania in 1994 to that in 2000?
Your answer should be very brief. 1.71. What is the ratio of the Value (constant 2005 US$) in Cyprus in 1994 to that in 2001?
Provide a succinct answer. 0.79. What is the ratio of the Value (constant 2005 US$) of Senegal in 1994 to that in 2001?
Make the answer very short. 0.85. What is the ratio of the Value (constant 2005 US$) of Tanzania in 1994 to that in 2001?
Provide a short and direct response. 1.62. What is the ratio of the Value (constant 2005 US$) of Cyprus in 1995 to that in 1996?
Keep it short and to the point. 0.93. What is the ratio of the Value (constant 2005 US$) of Senegal in 1995 to that in 1996?
Your answer should be compact. 0.98. What is the ratio of the Value (constant 2005 US$) in Tanzania in 1995 to that in 1996?
Your answer should be compact. 1.49. What is the ratio of the Value (constant 2005 US$) in Cyprus in 1995 to that in 1997?
Keep it short and to the point. 0.83. What is the ratio of the Value (constant 2005 US$) of Senegal in 1995 to that in 1997?
Give a very brief answer. 0.95. What is the ratio of the Value (constant 2005 US$) of Tanzania in 1995 to that in 1997?
Your response must be concise. 1.56. What is the ratio of the Value (constant 2005 US$) of Cyprus in 1995 to that in 1998?
Provide a short and direct response. 0.72. What is the ratio of the Value (constant 2005 US$) in Senegal in 1995 to that in 1998?
Ensure brevity in your answer.  0.94. What is the ratio of the Value (constant 2005 US$) of Tanzania in 1995 to that in 1998?
Give a very brief answer. 1.59. What is the ratio of the Value (constant 2005 US$) of Cyprus in 1995 to that in 1999?
Provide a succinct answer. 0.7. What is the ratio of the Value (constant 2005 US$) of Senegal in 1995 to that in 1999?
Provide a succinct answer. 0.86. What is the ratio of the Value (constant 2005 US$) of Tanzania in 1995 to that in 1999?
Ensure brevity in your answer.  1.61. What is the ratio of the Value (constant 2005 US$) of Cyprus in 1995 to that in 2000?
Keep it short and to the point. 0.72. What is the ratio of the Value (constant 2005 US$) in Senegal in 1995 to that in 2000?
Provide a short and direct response. 0.86. What is the ratio of the Value (constant 2005 US$) of Tanzania in 1995 to that in 2000?
Provide a short and direct response. 1.58. What is the ratio of the Value (constant 2005 US$) of Cyprus in 1995 to that in 2001?
Make the answer very short. 0.71. What is the ratio of the Value (constant 2005 US$) of Senegal in 1995 to that in 2001?
Your answer should be very brief. 0.85. What is the ratio of the Value (constant 2005 US$) in Tanzania in 1995 to that in 2001?
Provide a succinct answer. 1.49. What is the ratio of the Value (constant 2005 US$) of Cyprus in 1996 to that in 1997?
Keep it short and to the point. 0.9. What is the ratio of the Value (constant 2005 US$) in Senegal in 1996 to that in 1997?
Your response must be concise. 0.97. What is the ratio of the Value (constant 2005 US$) in Tanzania in 1996 to that in 1997?
Make the answer very short. 1.05. What is the ratio of the Value (constant 2005 US$) in Cyprus in 1996 to that in 1998?
Offer a very short reply. 0.78. What is the ratio of the Value (constant 2005 US$) in Senegal in 1996 to that in 1998?
Offer a terse response. 0.96. What is the ratio of the Value (constant 2005 US$) of Tanzania in 1996 to that in 1998?
Offer a very short reply. 1.07. What is the ratio of the Value (constant 2005 US$) in Cyprus in 1996 to that in 1999?
Offer a very short reply. 0.75. What is the ratio of the Value (constant 2005 US$) of Senegal in 1996 to that in 1999?
Ensure brevity in your answer.  0.88. What is the ratio of the Value (constant 2005 US$) in Tanzania in 1996 to that in 1999?
Make the answer very short. 1.08. What is the ratio of the Value (constant 2005 US$) of Cyprus in 1996 to that in 2000?
Give a very brief answer. 0.77. What is the ratio of the Value (constant 2005 US$) in Senegal in 1996 to that in 2000?
Your response must be concise. 0.88. What is the ratio of the Value (constant 2005 US$) of Tanzania in 1996 to that in 2000?
Provide a succinct answer. 1.06. What is the ratio of the Value (constant 2005 US$) in Cyprus in 1996 to that in 2001?
Offer a very short reply. 0.76. What is the ratio of the Value (constant 2005 US$) in Senegal in 1996 to that in 2001?
Your answer should be very brief. 0.87. What is the ratio of the Value (constant 2005 US$) of Cyprus in 1997 to that in 1998?
Keep it short and to the point. 0.87. What is the ratio of the Value (constant 2005 US$) in Senegal in 1997 to that in 1998?
Give a very brief answer. 0.99. What is the ratio of the Value (constant 2005 US$) of Tanzania in 1997 to that in 1998?
Ensure brevity in your answer.  1.02. What is the ratio of the Value (constant 2005 US$) of Senegal in 1997 to that in 1999?
Offer a very short reply. 0.91. What is the ratio of the Value (constant 2005 US$) of Tanzania in 1997 to that in 1999?
Keep it short and to the point. 1.03. What is the ratio of the Value (constant 2005 US$) of Cyprus in 1997 to that in 2000?
Give a very brief answer. 0.86. What is the ratio of the Value (constant 2005 US$) of Senegal in 1997 to that in 2000?
Your answer should be very brief. 0.91. What is the ratio of the Value (constant 2005 US$) of Tanzania in 1997 to that in 2000?
Your answer should be very brief. 1.01. What is the ratio of the Value (constant 2005 US$) of Cyprus in 1997 to that in 2001?
Your answer should be very brief. 0.85. What is the ratio of the Value (constant 2005 US$) of Senegal in 1997 to that in 2001?
Give a very brief answer. 0.9. What is the ratio of the Value (constant 2005 US$) in Tanzania in 1997 to that in 2001?
Your answer should be very brief. 0.95. What is the ratio of the Value (constant 2005 US$) in Cyprus in 1998 to that in 1999?
Ensure brevity in your answer.  0.96. What is the ratio of the Value (constant 2005 US$) of Senegal in 1998 to that in 1999?
Your answer should be compact. 0.92. What is the ratio of the Value (constant 2005 US$) of Tanzania in 1998 to that in 1999?
Provide a succinct answer. 1.02. What is the ratio of the Value (constant 2005 US$) in Senegal in 1998 to that in 2000?
Offer a terse response. 0.92. What is the ratio of the Value (constant 2005 US$) of Tanzania in 1998 to that in 2000?
Ensure brevity in your answer.  0.99. What is the ratio of the Value (constant 2005 US$) of Cyprus in 1998 to that in 2001?
Give a very brief answer. 0.98. What is the ratio of the Value (constant 2005 US$) of Senegal in 1998 to that in 2001?
Provide a short and direct response. 0.91. What is the ratio of the Value (constant 2005 US$) in Tanzania in 1998 to that in 2001?
Your answer should be very brief. 0.94. What is the ratio of the Value (constant 2005 US$) of Cyprus in 1999 to that in 2000?
Your answer should be very brief. 1.03. What is the ratio of the Value (constant 2005 US$) of Senegal in 1999 to that in 2000?
Offer a very short reply. 1. What is the ratio of the Value (constant 2005 US$) in Tanzania in 1999 to that in 2000?
Your answer should be compact. 0.98. What is the ratio of the Value (constant 2005 US$) in Cyprus in 1999 to that in 2001?
Ensure brevity in your answer.  1.02. What is the ratio of the Value (constant 2005 US$) in Senegal in 1999 to that in 2001?
Provide a short and direct response. 0.99. What is the ratio of the Value (constant 2005 US$) of Tanzania in 1999 to that in 2001?
Provide a short and direct response. 0.92. What is the ratio of the Value (constant 2005 US$) in Cyprus in 2000 to that in 2001?
Your answer should be very brief. 0.98. What is the ratio of the Value (constant 2005 US$) of Senegal in 2000 to that in 2001?
Give a very brief answer. 0.99. What is the ratio of the Value (constant 2005 US$) in Tanzania in 2000 to that in 2001?
Make the answer very short. 0.94. What is the difference between the highest and the second highest Value (constant 2005 US$) of Cyprus?
Offer a terse response. 4.25e+07. What is the difference between the highest and the second highest Value (constant 2005 US$) of Senegal?
Your answer should be very brief. 1.05e+07. What is the difference between the highest and the second highest Value (constant 2005 US$) of Tanzania?
Your answer should be compact. 1.83e+08. What is the difference between the highest and the lowest Value (constant 2005 US$) in Cyprus?
Offer a terse response. 7.71e+08. What is the difference between the highest and the lowest Value (constant 2005 US$) in Senegal?
Give a very brief answer. 1.51e+08. What is the difference between the highest and the lowest Value (constant 2005 US$) of Tanzania?
Offer a very short reply. 9.83e+08. 